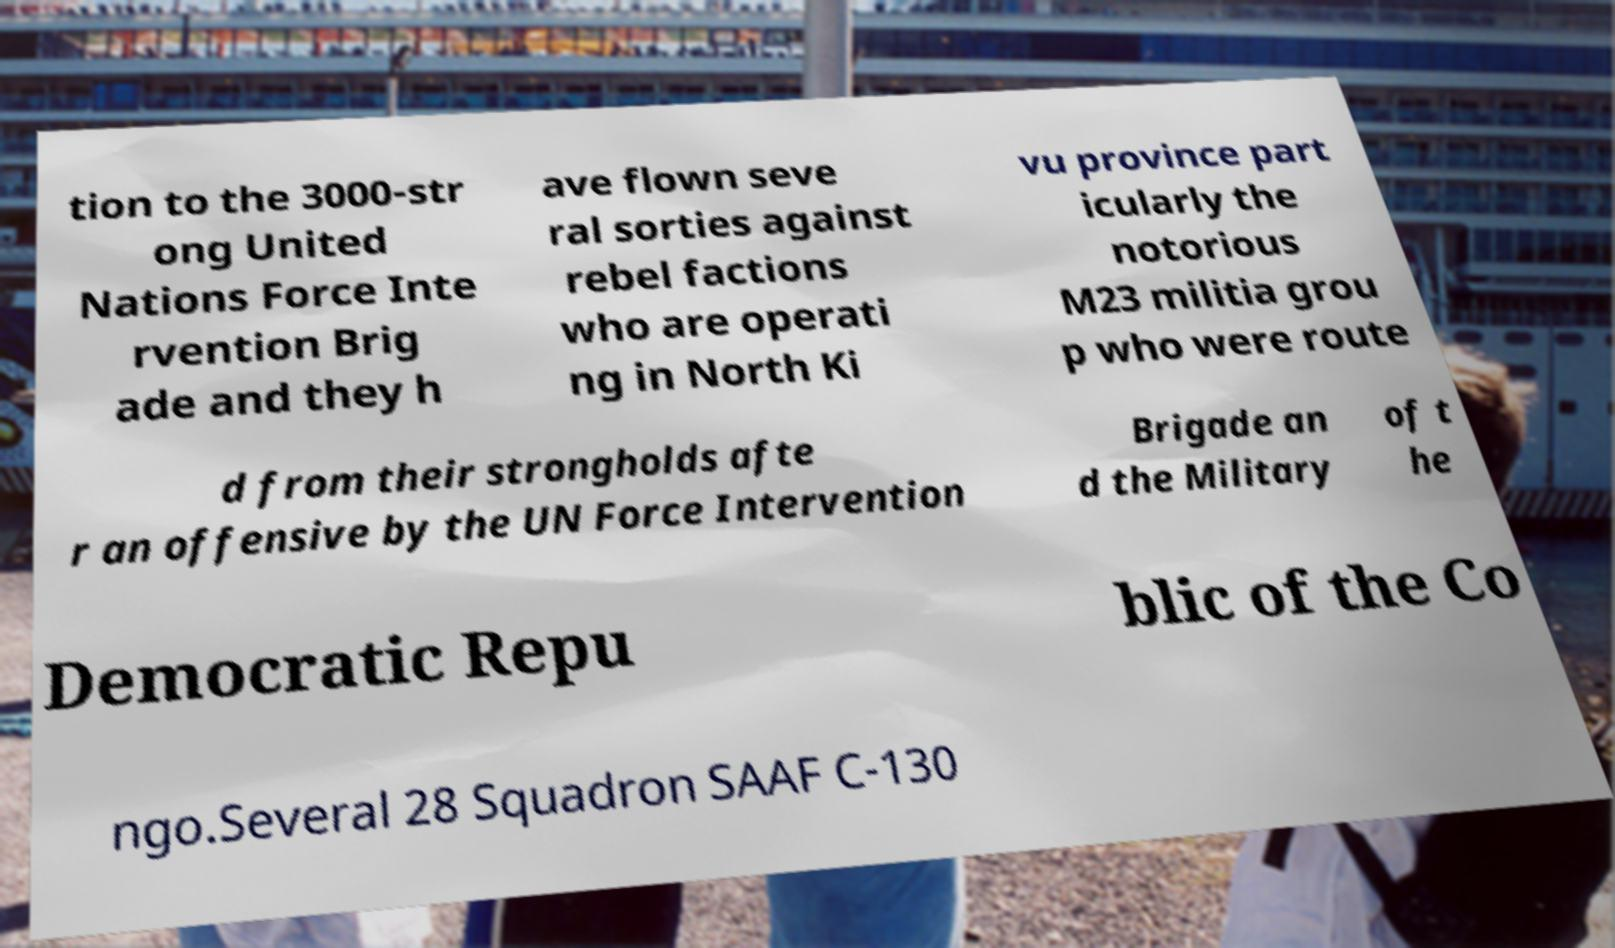Could you assist in decoding the text presented in this image and type it out clearly? tion to the 3000-str ong United Nations Force Inte rvention Brig ade and they h ave flown seve ral sorties against rebel factions who are operati ng in North Ki vu province part icularly the notorious M23 militia grou p who were route d from their strongholds afte r an offensive by the UN Force Intervention Brigade an d the Military of t he Democratic Repu blic of the Co ngo.Several 28 Squadron SAAF C-130 